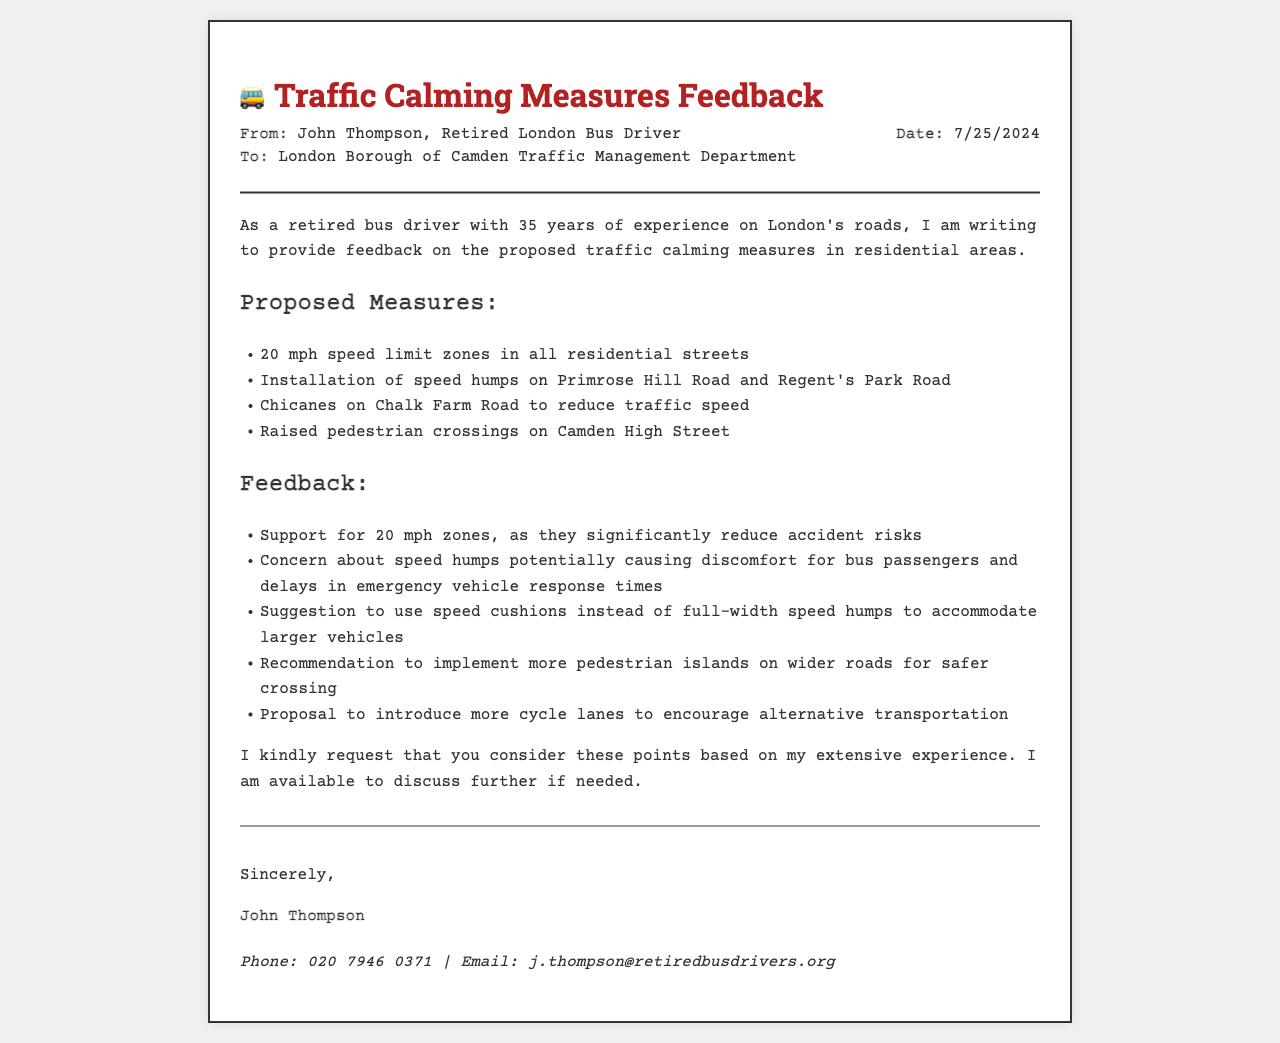what is the sender's name? The sender of the fax is John Thompson.
Answer: John Thompson what is the date of the fax? The date is dynamically generated and reflects the current date, which is today's date when viewed.
Answer: Current date what area do the proposed traffic calming measures concern? The proposed measures are specifically for residential areas.
Answer: residential areas how many years of experience does the sender have? The sender mentions having 35 years of experience as a bus driver.
Answer: 35 years what type of crossing is proposed on Camden High Street? The proposed crossing type mentioned is raised pedestrian crossings.
Answer: raised pedestrian crossings what is the suggested alternative to full-width speed humps? The document suggests using speed cushions instead of full-width speed humps.
Answer: speed cushions what is one of the recommendations related to pedestrians? The recommendation includes implementing more pedestrian islands on wider roads.
Answer: more pedestrian islands who is the recipient of the fax? The recipient of the fax is the London Borough of Camden Traffic Management Department.
Answer: London Borough of Camden Traffic Management Department what is the profession of the sender? The sender identifies as a retired London bus driver.
Answer: retired London bus driver 